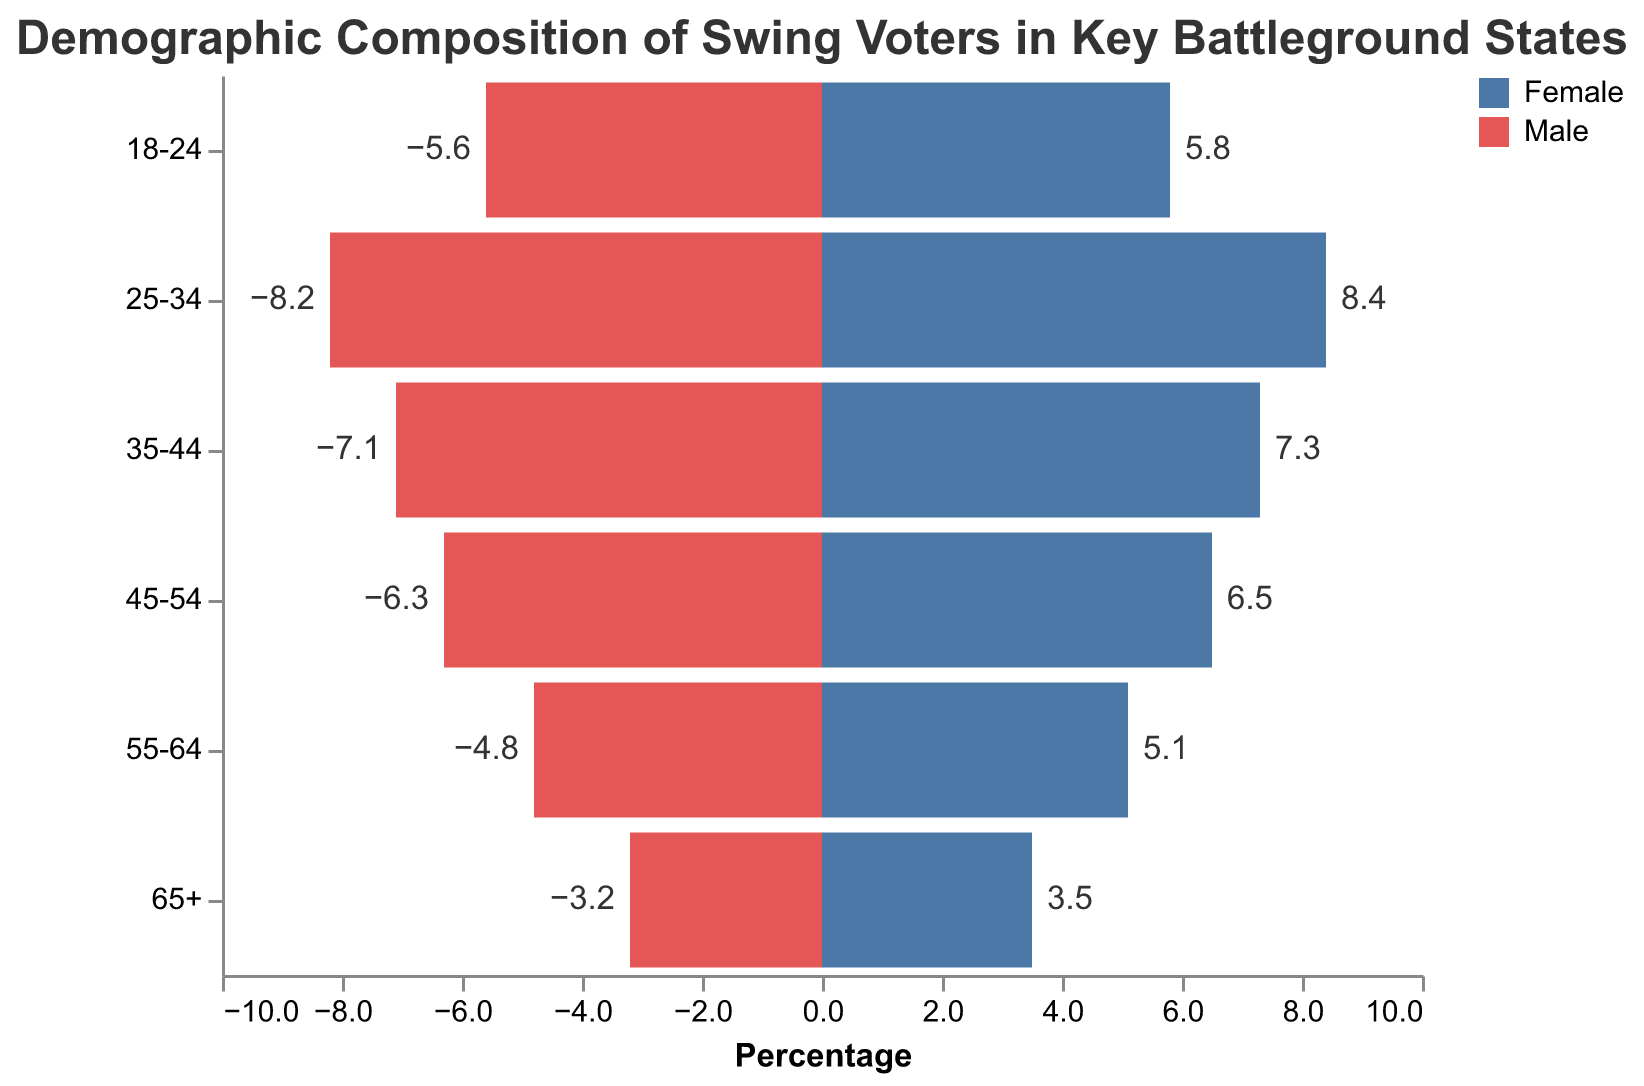Which age group has the highest percentage of female voters? The age group with the highest percentage of female voters can be identified by comparing the data points for the "Female" category. The "25-34" age group has the highest percentage at 8.4%.
Answer: "25-34" Which gender in the 45-54 age group has a higher percentage? To determine which gender has a higher percentage in the 45-54 age group, compare the values. The percentage for females (6.5%) is higher than for males (-6.3%).
Answer: Female What is the smallest percentage among male voters? The smallest percentage among male voters can be found by looking at the negative values for the "Male" category. The smallest value is -3.2% in the "65+" age group.
Answer: -3.2% What is the average percentage of voters in the 35-44 age group? To find the average percentage of voters in the 35-44 age group, sum the percentages for males and females (7.1 for males and 7.3 for females) and then divide by 2. The calculation is (7.1 + 7.3) / 2 = 7.2.
Answer: 7.2 How does the percentage of males in the 18-24 age group compare to that of females? Compare the percentages of males (-5.6%) and females (5.8%) in the 18-24 age group. Since 5.8 is higher than -5.6, females have a higher percentage.
Answer: Higher for females Is there any age group where male voters constitute more than female voters? Compare the percentages of male and female voters in each age group. In every age group, female voters have a higher percentage than male voters, so there is no age group where male voters constitute more than female voters.
Answer: No 